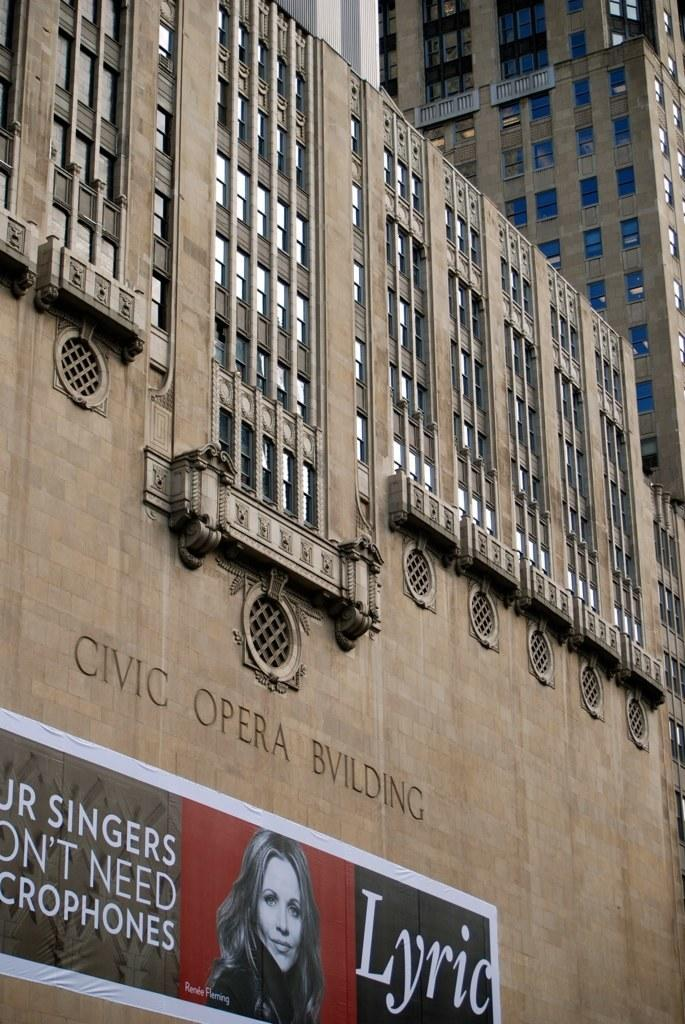What is located on a building in the foreground of the image? There is a banner on a building in the foreground of the image. What can be seen at the top of the image? There are buildings visible at the top of the image. What type of metal can be seen being used to construct the bed in the image? There is no bed present in the image, so it is not possible to determine what type of metal might be used in its construction. 